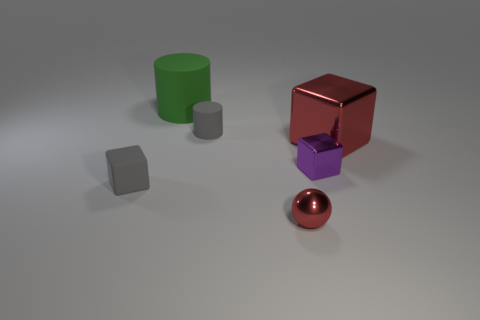Are there any other things that have the same shape as the tiny red shiny thing?
Your response must be concise. No. Are there fewer small metal blocks than small metallic things?
Provide a short and direct response. Yes. Are there any large purple objects made of the same material as the green cylinder?
Make the answer very short. No. There is a rubber thing right of the big green matte thing; what shape is it?
Give a very brief answer. Cylinder. Does the cylinder that is behind the tiny matte cylinder have the same color as the small cylinder?
Your answer should be very brief. No. Is the number of matte things to the right of the green matte cylinder less than the number of rubber objects?
Your answer should be compact. Yes. The tiny block that is made of the same material as the gray cylinder is what color?
Your answer should be very brief. Gray. What is the size of the gray matte thing that is left of the gray matte cylinder?
Provide a succinct answer. Small. Do the tiny cylinder and the purple cube have the same material?
Give a very brief answer. No. There is a gray thing behind the gray matte object in front of the red block; are there any rubber blocks that are behind it?
Your answer should be very brief. No. 